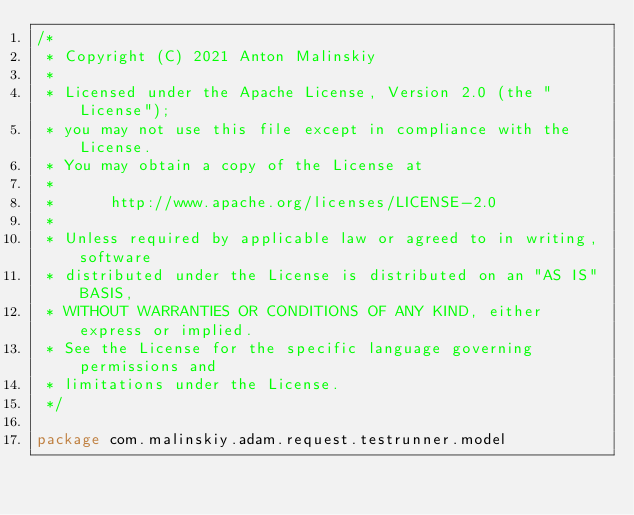Convert code to text. <code><loc_0><loc_0><loc_500><loc_500><_Kotlin_>/*
 * Copyright (C) 2021 Anton Malinskiy
 *
 * Licensed under the Apache License, Version 2.0 (the "License");
 * you may not use this file except in compliance with the License.
 * You may obtain a copy of the License at
 *
 *      http://www.apache.org/licenses/LICENSE-2.0
 *
 * Unless required by applicable law or agreed to in writing, software
 * distributed under the License is distributed on an "AS IS" BASIS,
 * WITHOUT WARRANTIES OR CONDITIONS OF ANY KIND, either express or implied.
 * See the License for the specific language governing permissions and
 * limitations under the License.
 */

package com.malinskiy.adam.request.testrunner.model
</code> 